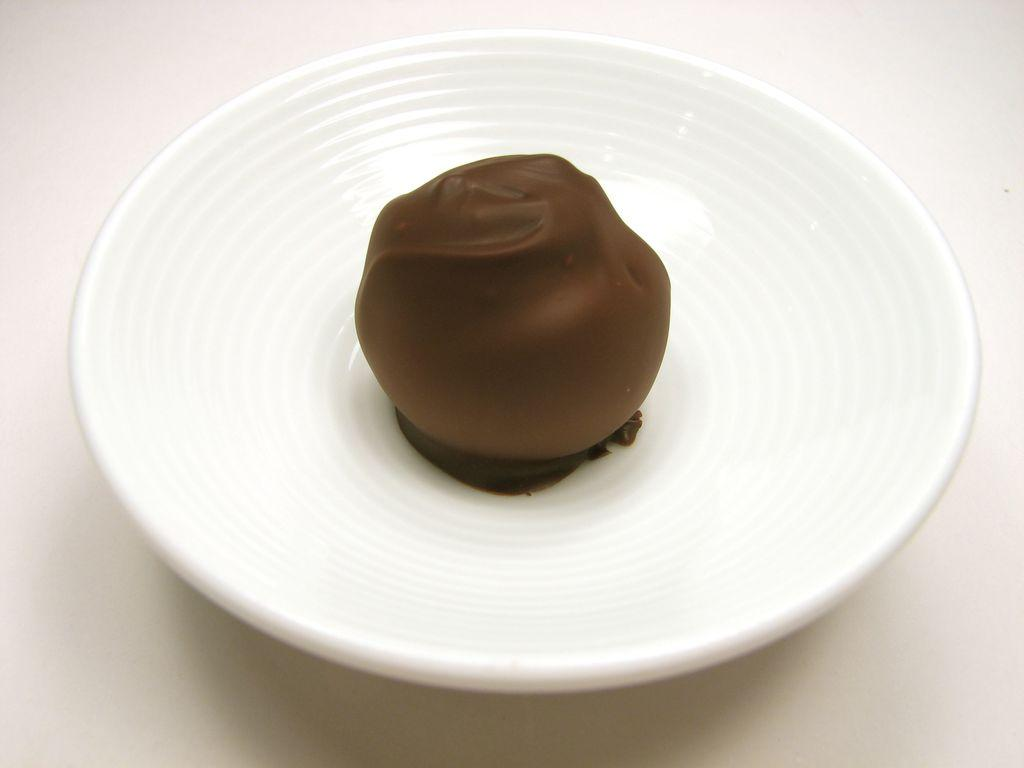What is the color of the surface in the image? The surface in the image is white. What is placed on the white surface? There is a bowl on the white surface. What is the color of the bowl? The bowl is white in color. What is inside the bowl? There is a food item in the bowl. How many goldfish are swimming in the bowl in the image? There are no goldfish in the image is not a typical fishbowl. A: There are no goldfish present in the image; the bowl contains a food item. 